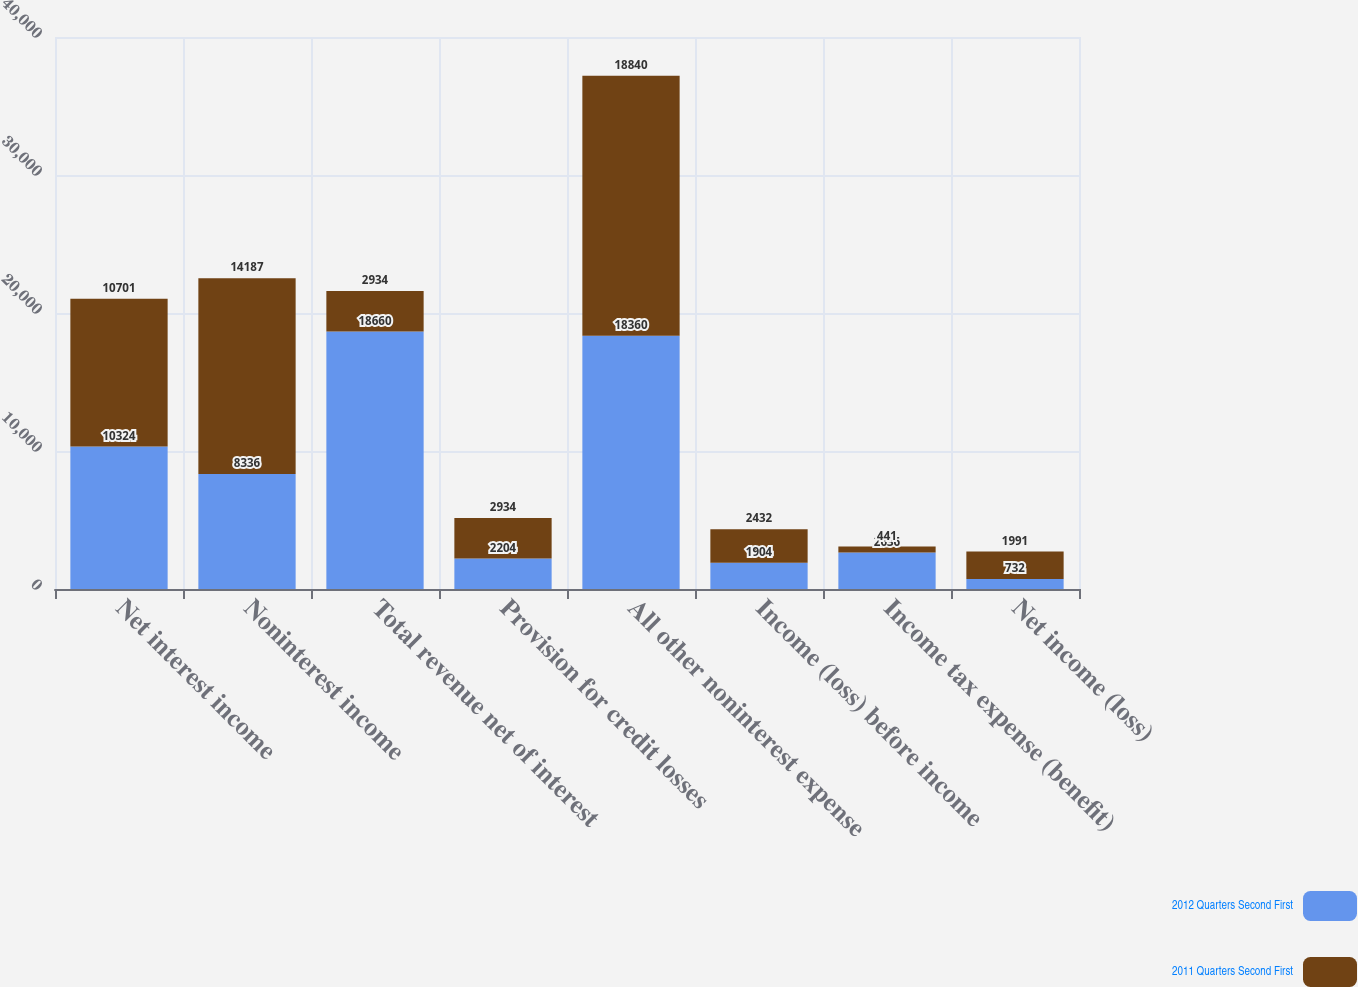Convert chart to OTSL. <chart><loc_0><loc_0><loc_500><loc_500><stacked_bar_chart><ecel><fcel>Net interest income<fcel>Noninterest income<fcel>Total revenue net of interest<fcel>Provision for credit losses<fcel>All other noninterest expense<fcel>Income (loss) before income<fcel>Income tax expense (benefit)<fcel>Net income (loss)<nl><fcel>2012 Quarters Second First<fcel>10324<fcel>8336<fcel>18660<fcel>2204<fcel>18360<fcel>1904<fcel>2636<fcel>732<nl><fcel>2011 Quarters Second First<fcel>10701<fcel>14187<fcel>2934<fcel>2934<fcel>18840<fcel>2432<fcel>441<fcel>1991<nl></chart> 